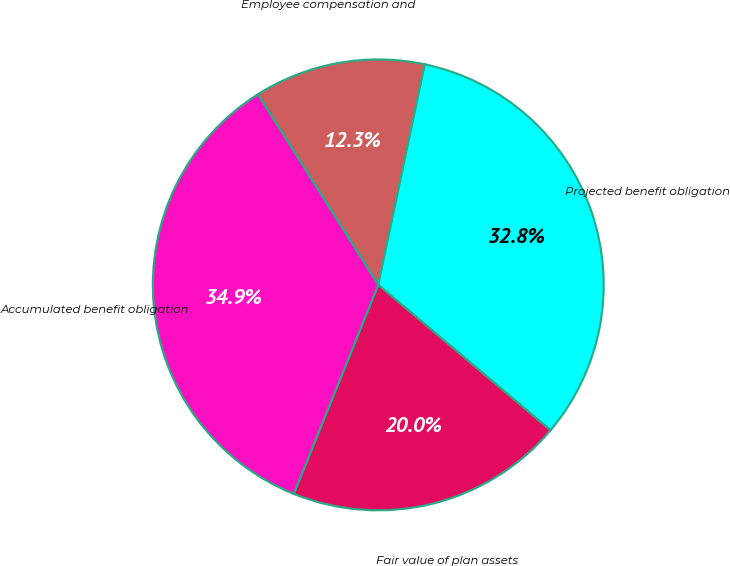Convert chart to OTSL. <chart><loc_0><loc_0><loc_500><loc_500><pie_chart><fcel>Employee compensation and<fcel>Projected benefit obligation<fcel>Fair value of plan assets<fcel>Accumulated benefit obligation<nl><fcel>12.28%<fcel>32.85%<fcel>19.96%<fcel>34.91%<nl></chart> 